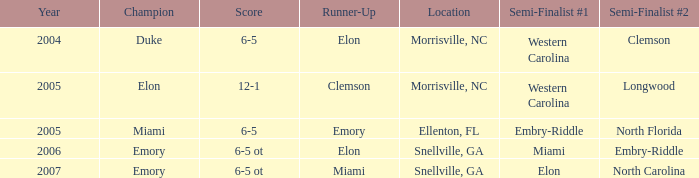Can you provide the scores of every game in which miami appeared as the initial semi-final team? 6-5 ot. 